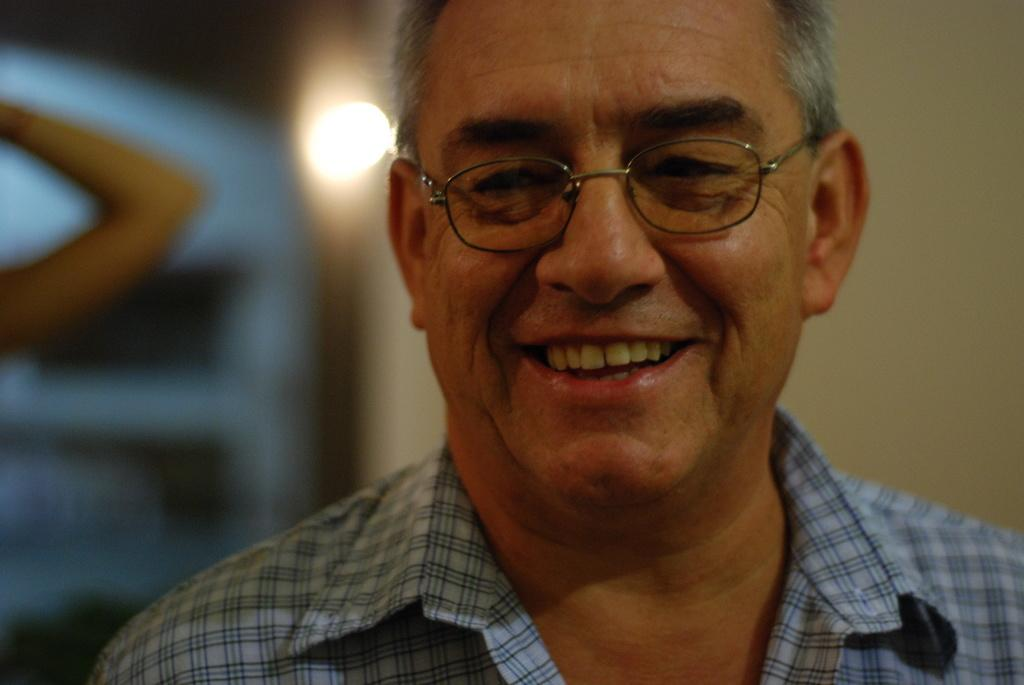What is the main subject of the image? There is a man in the image. What is the man wearing on his upper body? The man is wearing a shirt. Does the man have any accessories in the image? Yes, the man is wearing specs. How is the man's facial expression in the image? The man has a smile on his face. Can you describe the quality of the image? The image is slightly blurry in the background. What type of powder is being used to create the design on the man's shirt in the image? There is no powder or design visible on the man's shirt in the image. What message of peace is being conveyed by the man in the image? The image does not convey any specific message of peace; it simply shows a man with a smile on his face. 